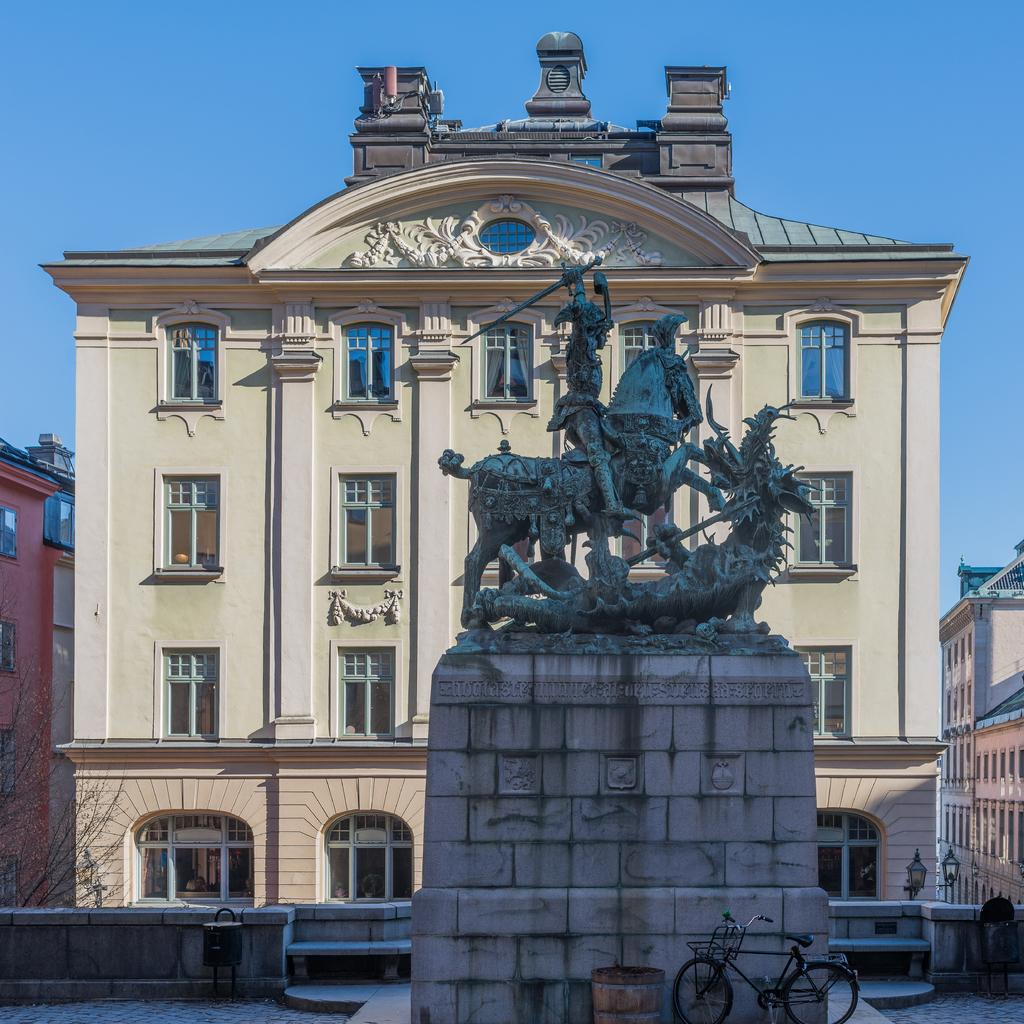What is the main subject in the image? There is a statue in the image. What is located in front of the statue? There is a bicycle in front of the statue. What can be seen in the background of the image? There are buildings in the background of the image. What colors are the buildings? The buildings are in cream and brown colors. What is the color of the sky in the image? The sky is white in color. Can you see a stream of water flowing near the statue in the image? There is no stream of water visible in the image. What type of chalk is being used to draw on the statue in the image? There is no chalk or drawing on the statue in the image. 